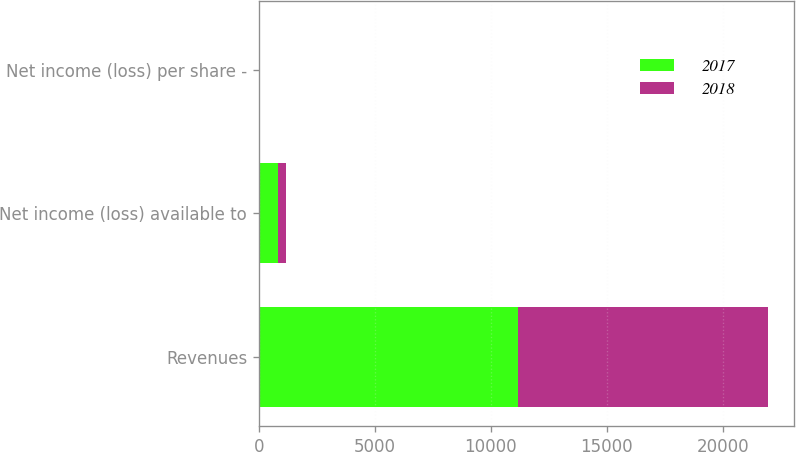Convert chart to OTSL. <chart><loc_0><loc_0><loc_500><loc_500><stacked_bar_chart><ecel><fcel>Revenues<fcel>Net income (loss) available to<fcel>Net income (loss) per share -<nl><fcel>2017<fcel>11176<fcel>823<fcel>1.15<nl><fcel>2018<fcel>10790<fcel>329<fcel>0.47<nl></chart> 